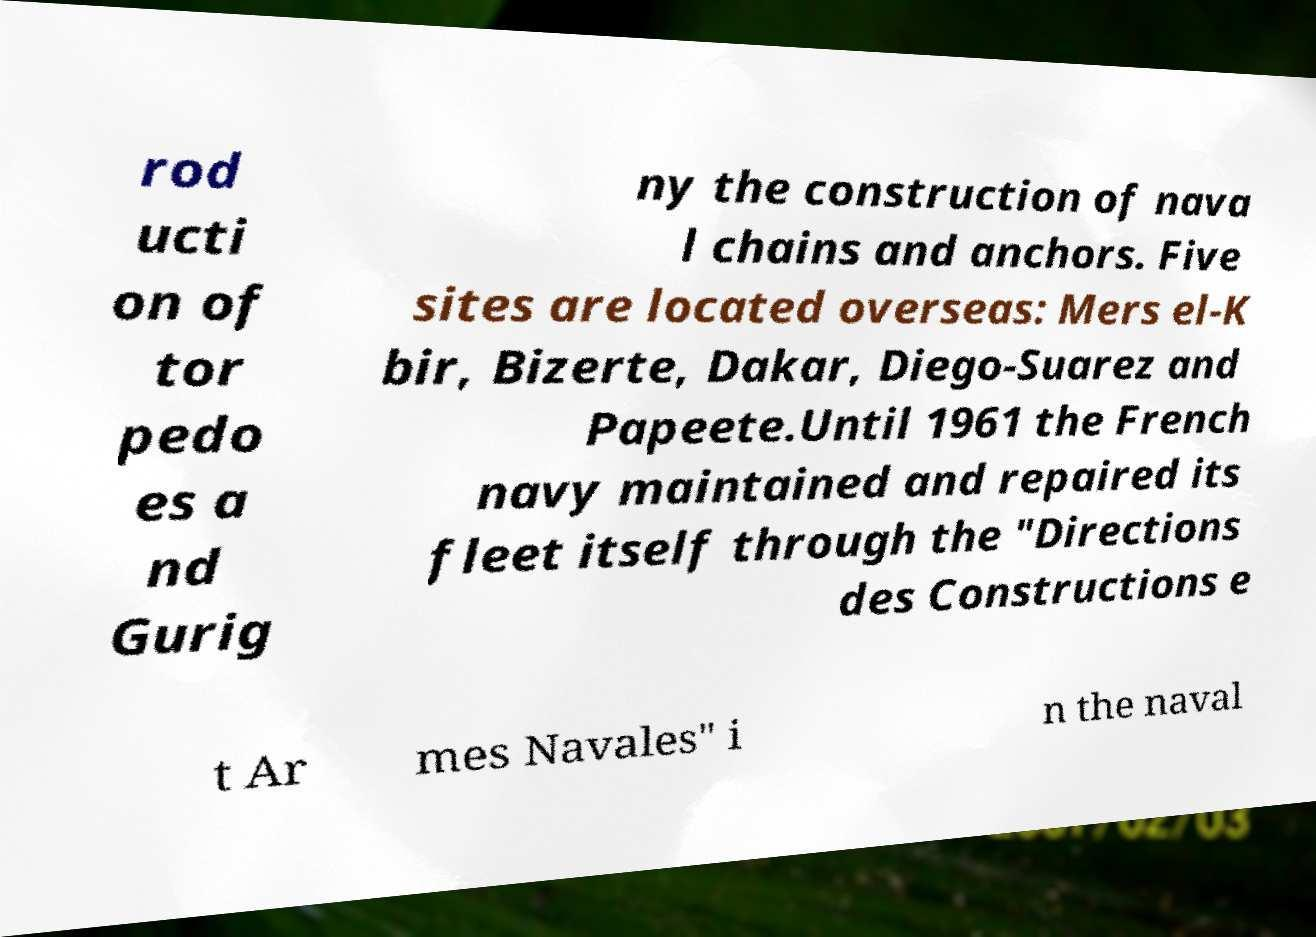For documentation purposes, I need the text within this image transcribed. Could you provide that? rod ucti on of tor pedo es a nd Gurig ny the construction of nava l chains and anchors. Five sites are located overseas: Mers el-K bir, Bizerte, Dakar, Diego-Suarez and Papeete.Until 1961 the French navy maintained and repaired its fleet itself through the "Directions des Constructions e t Ar mes Navales" i n the naval 